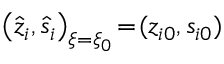<formula> <loc_0><loc_0><loc_500><loc_500>\left ( \hat { z } _ { i } , \hat { s } _ { i } \right ) _ { \xi = \xi _ { 0 } } \, = \, ( z _ { i 0 } , s _ { i 0 } )</formula> 